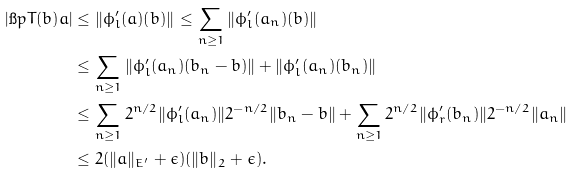<formula> <loc_0><loc_0><loc_500><loc_500>| \i p { T ( b ) } { a } | & \leq \| \phi _ { l } ^ { \prime } ( a ) ( b ) \| \leq \sum _ { n \geq 1 } \| \phi _ { l } ^ { \prime } ( a _ { n } ) ( b ) \| \\ & \leq \sum _ { n \geq 1 } \| \phi _ { l } ^ { \prime } ( a _ { n } ) ( b _ { n } - b ) \| + \| \phi _ { l } ^ { \prime } ( a _ { n } ) ( b _ { n } ) \| \\ & \leq \sum _ { n \geq 1 } 2 ^ { n / 2 } \| \phi _ { l } ^ { \prime } ( a _ { n } ) \| 2 ^ { - n / 2 } \| b _ { n } - b \| + \sum _ { n \geq 1 } 2 ^ { n / 2 } \| \phi _ { r } ^ { \prime } ( b _ { n } ) \| 2 ^ { - n / 2 } \| a _ { n } \| \\ & \leq 2 ( \| a \| _ { E ^ { \prime } } + \epsilon ) ( \| b \| _ { 2 } + \epsilon ) .</formula> 